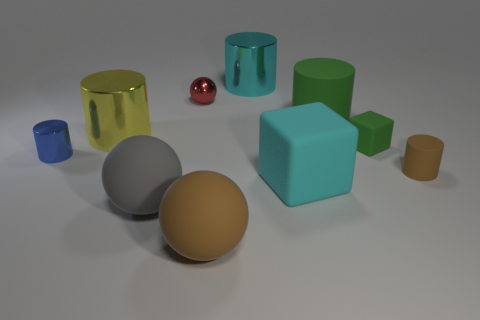Can you describe the texture of the objects? The objects in the image have a variety of textures. The balls and cylinders seem to have a smooth and possibly shiny texture, evident by the light reflections on their surfaces, whereas the blocks appear matte with diffuse reflections, suggesting a rougher texture. 